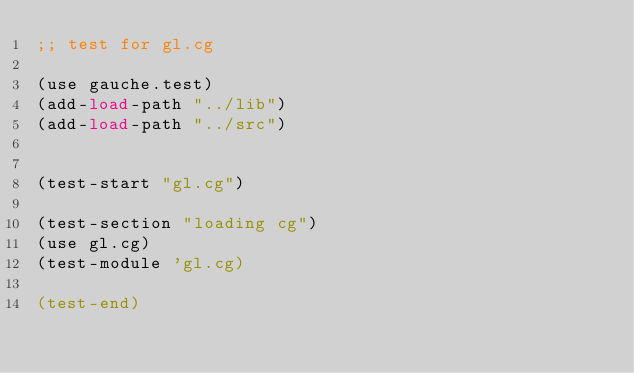Convert code to text. <code><loc_0><loc_0><loc_500><loc_500><_Scheme_>;; test for gl.cg

(use gauche.test)
(add-load-path "../lib")
(add-load-path "../src")


(test-start "gl.cg")

(test-section "loading cg")
(use gl.cg)
(test-module 'gl.cg)

(test-end)
</code> 